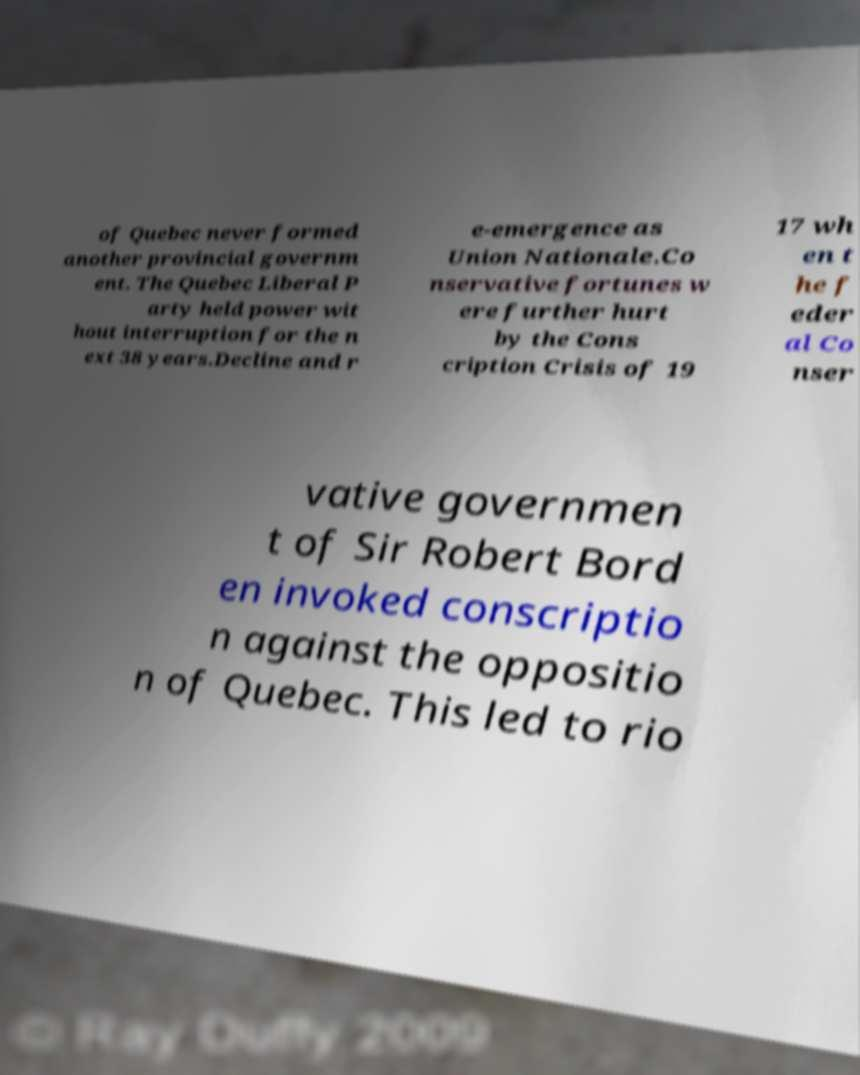Please identify and transcribe the text found in this image. of Quebec never formed another provincial governm ent. The Quebec Liberal P arty held power wit hout interruption for the n ext 38 years.Decline and r e-emergence as Union Nationale.Co nservative fortunes w ere further hurt by the Cons cription Crisis of 19 17 wh en t he f eder al Co nser vative governmen t of Sir Robert Bord en invoked conscriptio n against the oppositio n of Quebec. This led to rio 